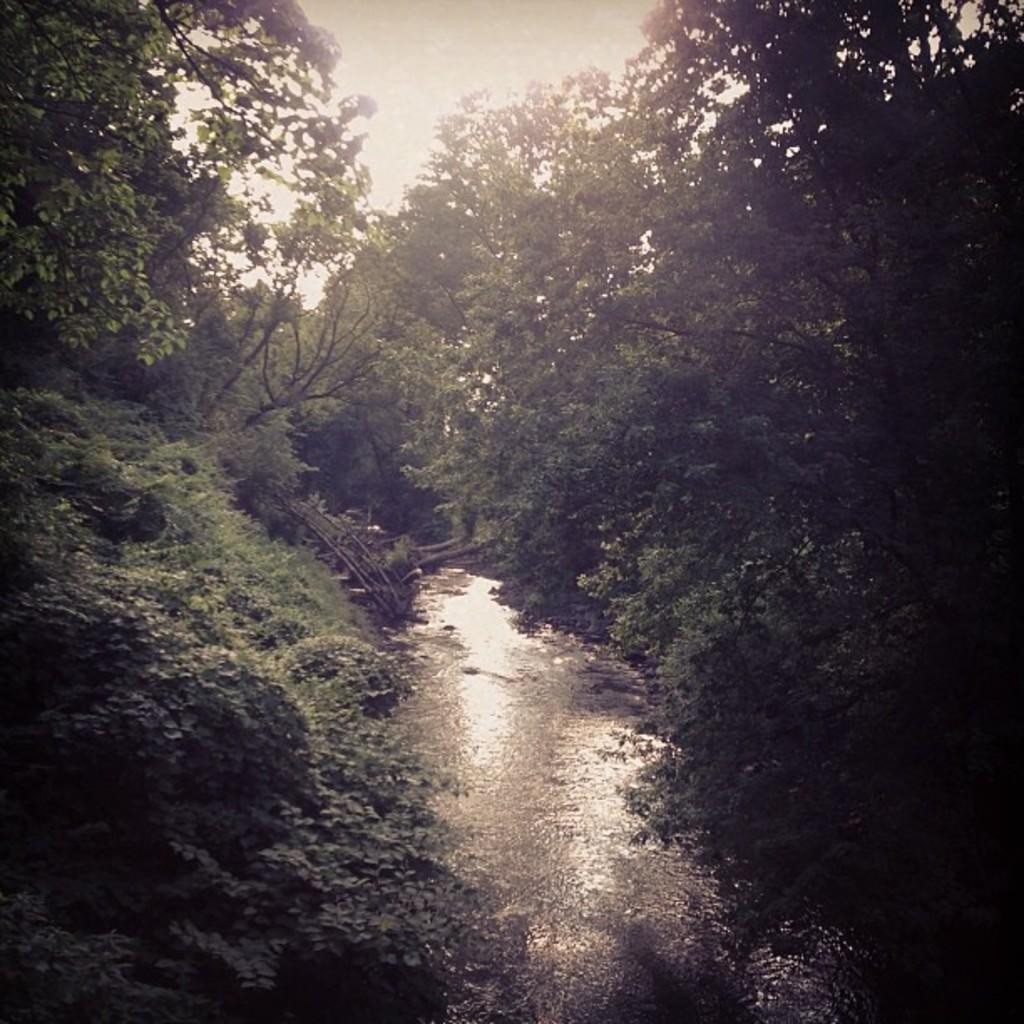What type of environment is shown in the image? The image appears to depict a forest. Can you describe any specific features of the forest? There is a small canal with water flowing in the image. What type of trees can be seen in the forest? Trees with branches and leaves are present in the image. How does the decision-making process of the winged creature in the image affect the water flow? There is no winged creature present in the image, so it is not possible to determine how its decision-making process might affect the water flow. 